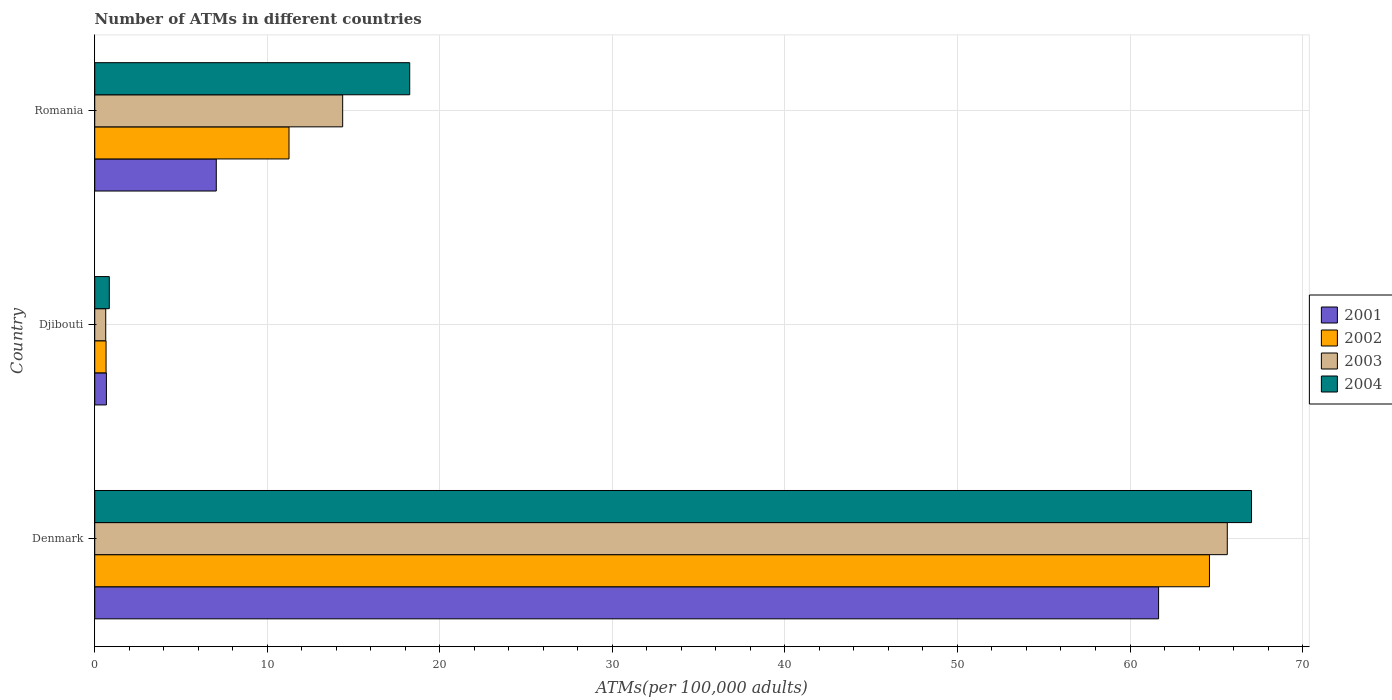Are the number of bars on each tick of the Y-axis equal?
Your answer should be very brief. Yes. How many bars are there on the 1st tick from the top?
Your answer should be very brief. 4. What is the number of ATMs in 2001 in Romania?
Your answer should be compact. 7.04. Across all countries, what is the maximum number of ATMs in 2003?
Your response must be concise. 65.64. Across all countries, what is the minimum number of ATMs in 2004?
Your answer should be very brief. 0.84. In which country was the number of ATMs in 2002 minimum?
Make the answer very short. Djibouti. What is the total number of ATMs in 2002 in the graph?
Make the answer very short. 76.52. What is the difference between the number of ATMs in 2002 in Djibouti and that in Romania?
Offer a terse response. -10.6. What is the difference between the number of ATMs in 2001 in Denmark and the number of ATMs in 2004 in Djibouti?
Your answer should be compact. 60.81. What is the average number of ATMs in 2004 per country?
Your answer should be very brief. 28.71. What is the difference between the number of ATMs in 2001 and number of ATMs in 2004 in Djibouti?
Provide a short and direct response. -0.17. What is the ratio of the number of ATMs in 2003 in Djibouti to that in Romania?
Your answer should be very brief. 0.04. Is the difference between the number of ATMs in 2001 in Denmark and Djibouti greater than the difference between the number of ATMs in 2004 in Denmark and Djibouti?
Your answer should be very brief. No. What is the difference between the highest and the second highest number of ATMs in 2003?
Provide a short and direct response. 51.27. What is the difference between the highest and the lowest number of ATMs in 2001?
Keep it short and to the point. 60.98. In how many countries, is the number of ATMs in 2001 greater than the average number of ATMs in 2001 taken over all countries?
Offer a very short reply. 1. Is the sum of the number of ATMs in 2003 in Denmark and Djibouti greater than the maximum number of ATMs in 2002 across all countries?
Provide a short and direct response. Yes. Is it the case that in every country, the sum of the number of ATMs in 2002 and number of ATMs in 2001 is greater than the number of ATMs in 2003?
Ensure brevity in your answer.  Yes. Are all the bars in the graph horizontal?
Your answer should be very brief. Yes. How many countries are there in the graph?
Offer a very short reply. 3. What is the difference between two consecutive major ticks on the X-axis?
Offer a terse response. 10. Are the values on the major ticks of X-axis written in scientific E-notation?
Give a very brief answer. No. Does the graph contain grids?
Offer a very short reply. Yes. Where does the legend appear in the graph?
Give a very brief answer. Center right. What is the title of the graph?
Keep it short and to the point. Number of ATMs in different countries. What is the label or title of the X-axis?
Ensure brevity in your answer.  ATMs(per 100,0 adults). What is the ATMs(per 100,000 adults) of 2001 in Denmark?
Keep it short and to the point. 61.66. What is the ATMs(per 100,000 adults) in 2002 in Denmark?
Offer a terse response. 64.61. What is the ATMs(per 100,000 adults) in 2003 in Denmark?
Provide a succinct answer. 65.64. What is the ATMs(per 100,000 adults) in 2004 in Denmark?
Provide a succinct answer. 67.04. What is the ATMs(per 100,000 adults) in 2001 in Djibouti?
Make the answer very short. 0.68. What is the ATMs(per 100,000 adults) of 2002 in Djibouti?
Keep it short and to the point. 0.66. What is the ATMs(per 100,000 adults) of 2003 in Djibouti?
Provide a short and direct response. 0.64. What is the ATMs(per 100,000 adults) of 2004 in Djibouti?
Your answer should be compact. 0.84. What is the ATMs(per 100,000 adults) of 2001 in Romania?
Provide a succinct answer. 7.04. What is the ATMs(per 100,000 adults) in 2002 in Romania?
Your answer should be compact. 11.26. What is the ATMs(per 100,000 adults) in 2003 in Romania?
Your answer should be very brief. 14.37. What is the ATMs(per 100,000 adults) of 2004 in Romania?
Your response must be concise. 18.26. Across all countries, what is the maximum ATMs(per 100,000 adults) in 2001?
Ensure brevity in your answer.  61.66. Across all countries, what is the maximum ATMs(per 100,000 adults) of 2002?
Keep it short and to the point. 64.61. Across all countries, what is the maximum ATMs(per 100,000 adults) of 2003?
Keep it short and to the point. 65.64. Across all countries, what is the maximum ATMs(per 100,000 adults) in 2004?
Your answer should be very brief. 67.04. Across all countries, what is the minimum ATMs(per 100,000 adults) in 2001?
Provide a short and direct response. 0.68. Across all countries, what is the minimum ATMs(per 100,000 adults) in 2002?
Give a very brief answer. 0.66. Across all countries, what is the minimum ATMs(per 100,000 adults) in 2003?
Provide a short and direct response. 0.64. Across all countries, what is the minimum ATMs(per 100,000 adults) of 2004?
Offer a terse response. 0.84. What is the total ATMs(per 100,000 adults) of 2001 in the graph?
Provide a short and direct response. 69.38. What is the total ATMs(per 100,000 adults) of 2002 in the graph?
Give a very brief answer. 76.52. What is the total ATMs(per 100,000 adults) in 2003 in the graph?
Keep it short and to the point. 80.65. What is the total ATMs(per 100,000 adults) in 2004 in the graph?
Provide a short and direct response. 86.14. What is the difference between the ATMs(per 100,000 adults) in 2001 in Denmark and that in Djibouti?
Keep it short and to the point. 60.98. What is the difference between the ATMs(per 100,000 adults) of 2002 in Denmark and that in Djibouti?
Ensure brevity in your answer.  63.95. What is the difference between the ATMs(per 100,000 adults) in 2003 in Denmark and that in Djibouti?
Provide a succinct answer. 65. What is the difference between the ATMs(per 100,000 adults) of 2004 in Denmark and that in Djibouti?
Provide a short and direct response. 66.2. What is the difference between the ATMs(per 100,000 adults) of 2001 in Denmark and that in Romania?
Offer a very short reply. 54.61. What is the difference between the ATMs(per 100,000 adults) in 2002 in Denmark and that in Romania?
Provide a short and direct response. 53.35. What is the difference between the ATMs(per 100,000 adults) in 2003 in Denmark and that in Romania?
Your answer should be compact. 51.27. What is the difference between the ATMs(per 100,000 adults) of 2004 in Denmark and that in Romania?
Provide a short and direct response. 48.79. What is the difference between the ATMs(per 100,000 adults) of 2001 in Djibouti and that in Romania?
Offer a terse response. -6.37. What is the difference between the ATMs(per 100,000 adults) in 2002 in Djibouti and that in Romania?
Keep it short and to the point. -10.6. What is the difference between the ATMs(per 100,000 adults) of 2003 in Djibouti and that in Romania?
Provide a short and direct response. -13.73. What is the difference between the ATMs(per 100,000 adults) of 2004 in Djibouti and that in Romania?
Your answer should be compact. -17.41. What is the difference between the ATMs(per 100,000 adults) in 2001 in Denmark and the ATMs(per 100,000 adults) in 2002 in Djibouti?
Make the answer very short. 61. What is the difference between the ATMs(per 100,000 adults) of 2001 in Denmark and the ATMs(per 100,000 adults) of 2003 in Djibouti?
Offer a terse response. 61.02. What is the difference between the ATMs(per 100,000 adults) in 2001 in Denmark and the ATMs(per 100,000 adults) in 2004 in Djibouti?
Offer a very short reply. 60.81. What is the difference between the ATMs(per 100,000 adults) in 2002 in Denmark and the ATMs(per 100,000 adults) in 2003 in Djibouti?
Give a very brief answer. 63.97. What is the difference between the ATMs(per 100,000 adults) of 2002 in Denmark and the ATMs(per 100,000 adults) of 2004 in Djibouti?
Offer a very short reply. 63.76. What is the difference between the ATMs(per 100,000 adults) in 2003 in Denmark and the ATMs(per 100,000 adults) in 2004 in Djibouti?
Provide a succinct answer. 64.79. What is the difference between the ATMs(per 100,000 adults) in 2001 in Denmark and the ATMs(per 100,000 adults) in 2002 in Romania?
Make the answer very short. 50.4. What is the difference between the ATMs(per 100,000 adults) of 2001 in Denmark and the ATMs(per 100,000 adults) of 2003 in Romania?
Give a very brief answer. 47.29. What is the difference between the ATMs(per 100,000 adults) in 2001 in Denmark and the ATMs(per 100,000 adults) in 2004 in Romania?
Give a very brief answer. 43.4. What is the difference between the ATMs(per 100,000 adults) of 2002 in Denmark and the ATMs(per 100,000 adults) of 2003 in Romania?
Provide a short and direct response. 50.24. What is the difference between the ATMs(per 100,000 adults) in 2002 in Denmark and the ATMs(per 100,000 adults) in 2004 in Romania?
Offer a terse response. 46.35. What is the difference between the ATMs(per 100,000 adults) of 2003 in Denmark and the ATMs(per 100,000 adults) of 2004 in Romania?
Your response must be concise. 47.38. What is the difference between the ATMs(per 100,000 adults) in 2001 in Djibouti and the ATMs(per 100,000 adults) in 2002 in Romania?
Keep it short and to the point. -10.58. What is the difference between the ATMs(per 100,000 adults) of 2001 in Djibouti and the ATMs(per 100,000 adults) of 2003 in Romania?
Your answer should be compact. -13.69. What is the difference between the ATMs(per 100,000 adults) of 2001 in Djibouti and the ATMs(per 100,000 adults) of 2004 in Romania?
Your answer should be very brief. -17.58. What is the difference between the ATMs(per 100,000 adults) in 2002 in Djibouti and the ATMs(per 100,000 adults) in 2003 in Romania?
Provide a succinct answer. -13.71. What is the difference between the ATMs(per 100,000 adults) in 2002 in Djibouti and the ATMs(per 100,000 adults) in 2004 in Romania?
Make the answer very short. -17.6. What is the difference between the ATMs(per 100,000 adults) of 2003 in Djibouti and the ATMs(per 100,000 adults) of 2004 in Romania?
Ensure brevity in your answer.  -17.62. What is the average ATMs(per 100,000 adults) of 2001 per country?
Make the answer very short. 23.13. What is the average ATMs(per 100,000 adults) of 2002 per country?
Your response must be concise. 25.51. What is the average ATMs(per 100,000 adults) of 2003 per country?
Make the answer very short. 26.88. What is the average ATMs(per 100,000 adults) of 2004 per country?
Your answer should be very brief. 28.71. What is the difference between the ATMs(per 100,000 adults) in 2001 and ATMs(per 100,000 adults) in 2002 in Denmark?
Keep it short and to the point. -2.95. What is the difference between the ATMs(per 100,000 adults) in 2001 and ATMs(per 100,000 adults) in 2003 in Denmark?
Ensure brevity in your answer.  -3.98. What is the difference between the ATMs(per 100,000 adults) in 2001 and ATMs(per 100,000 adults) in 2004 in Denmark?
Provide a succinct answer. -5.39. What is the difference between the ATMs(per 100,000 adults) in 2002 and ATMs(per 100,000 adults) in 2003 in Denmark?
Provide a short and direct response. -1.03. What is the difference between the ATMs(per 100,000 adults) of 2002 and ATMs(per 100,000 adults) of 2004 in Denmark?
Your answer should be very brief. -2.44. What is the difference between the ATMs(per 100,000 adults) in 2003 and ATMs(per 100,000 adults) in 2004 in Denmark?
Your answer should be very brief. -1.41. What is the difference between the ATMs(per 100,000 adults) in 2001 and ATMs(per 100,000 adults) in 2002 in Djibouti?
Your answer should be very brief. 0.02. What is the difference between the ATMs(per 100,000 adults) of 2001 and ATMs(per 100,000 adults) of 2003 in Djibouti?
Ensure brevity in your answer.  0.04. What is the difference between the ATMs(per 100,000 adults) in 2001 and ATMs(per 100,000 adults) in 2004 in Djibouti?
Keep it short and to the point. -0.17. What is the difference between the ATMs(per 100,000 adults) of 2002 and ATMs(per 100,000 adults) of 2003 in Djibouti?
Your answer should be very brief. 0.02. What is the difference between the ATMs(per 100,000 adults) of 2002 and ATMs(per 100,000 adults) of 2004 in Djibouti?
Ensure brevity in your answer.  -0.19. What is the difference between the ATMs(per 100,000 adults) in 2003 and ATMs(per 100,000 adults) in 2004 in Djibouti?
Ensure brevity in your answer.  -0.21. What is the difference between the ATMs(per 100,000 adults) in 2001 and ATMs(per 100,000 adults) in 2002 in Romania?
Give a very brief answer. -4.21. What is the difference between the ATMs(per 100,000 adults) of 2001 and ATMs(per 100,000 adults) of 2003 in Romania?
Give a very brief answer. -7.32. What is the difference between the ATMs(per 100,000 adults) in 2001 and ATMs(per 100,000 adults) in 2004 in Romania?
Give a very brief answer. -11.21. What is the difference between the ATMs(per 100,000 adults) in 2002 and ATMs(per 100,000 adults) in 2003 in Romania?
Offer a very short reply. -3.11. What is the difference between the ATMs(per 100,000 adults) of 2002 and ATMs(per 100,000 adults) of 2004 in Romania?
Offer a very short reply. -7. What is the difference between the ATMs(per 100,000 adults) in 2003 and ATMs(per 100,000 adults) in 2004 in Romania?
Make the answer very short. -3.89. What is the ratio of the ATMs(per 100,000 adults) in 2001 in Denmark to that in Djibouti?
Provide a short and direct response. 91.18. What is the ratio of the ATMs(per 100,000 adults) of 2002 in Denmark to that in Djibouti?
Your answer should be very brief. 98.45. What is the ratio of the ATMs(per 100,000 adults) of 2003 in Denmark to that in Djibouti?
Keep it short and to the point. 102.88. What is the ratio of the ATMs(per 100,000 adults) in 2004 in Denmark to that in Djibouti?
Keep it short and to the point. 79.46. What is the ratio of the ATMs(per 100,000 adults) in 2001 in Denmark to that in Romania?
Your answer should be very brief. 8.75. What is the ratio of the ATMs(per 100,000 adults) of 2002 in Denmark to that in Romania?
Your answer should be compact. 5.74. What is the ratio of the ATMs(per 100,000 adults) in 2003 in Denmark to that in Romania?
Provide a short and direct response. 4.57. What is the ratio of the ATMs(per 100,000 adults) in 2004 in Denmark to that in Romania?
Offer a terse response. 3.67. What is the ratio of the ATMs(per 100,000 adults) of 2001 in Djibouti to that in Romania?
Your answer should be very brief. 0.1. What is the ratio of the ATMs(per 100,000 adults) of 2002 in Djibouti to that in Romania?
Offer a very short reply. 0.06. What is the ratio of the ATMs(per 100,000 adults) in 2003 in Djibouti to that in Romania?
Offer a terse response. 0.04. What is the ratio of the ATMs(per 100,000 adults) in 2004 in Djibouti to that in Romania?
Provide a short and direct response. 0.05. What is the difference between the highest and the second highest ATMs(per 100,000 adults) in 2001?
Your answer should be compact. 54.61. What is the difference between the highest and the second highest ATMs(per 100,000 adults) of 2002?
Your answer should be compact. 53.35. What is the difference between the highest and the second highest ATMs(per 100,000 adults) of 2003?
Provide a succinct answer. 51.27. What is the difference between the highest and the second highest ATMs(per 100,000 adults) of 2004?
Provide a short and direct response. 48.79. What is the difference between the highest and the lowest ATMs(per 100,000 adults) of 2001?
Make the answer very short. 60.98. What is the difference between the highest and the lowest ATMs(per 100,000 adults) of 2002?
Provide a short and direct response. 63.95. What is the difference between the highest and the lowest ATMs(per 100,000 adults) in 2003?
Your answer should be very brief. 65. What is the difference between the highest and the lowest ATMs(per 100,000 adults) of 2004?
Offer a very short reply. 66.2. 